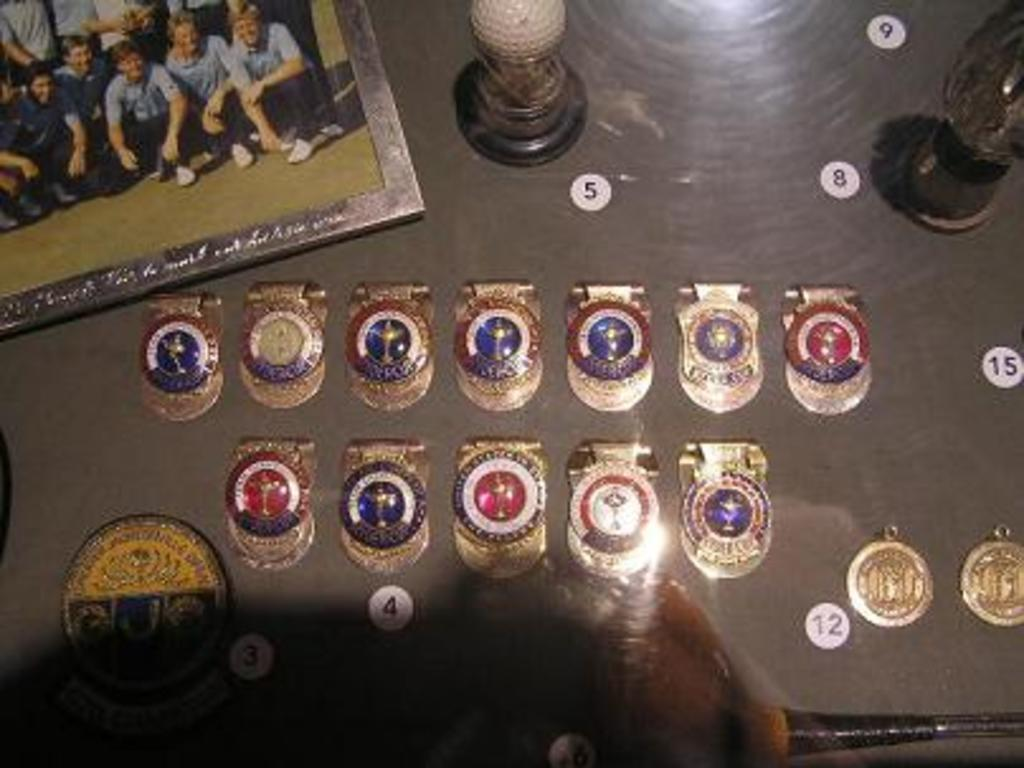<image>
Relay a brief, clear account of the picture shown. Several gold watches laid out on a table next to number stickers like 12 along with a group picture in the corner. 